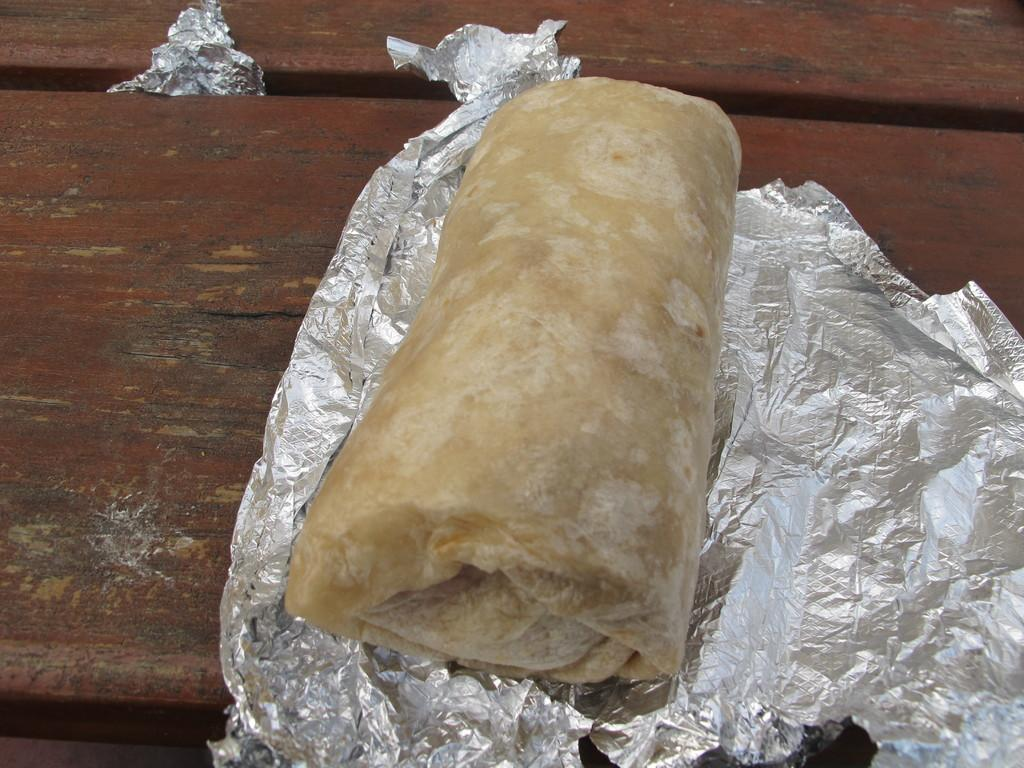What material is the plank in the image made of? The wooden plank in the image is made of wood. What is placed on the wooden plank? There is a food item wrapped in silver paper on the wooden plank. What type of notebook is visible on the wooden plank? There is no notebook present on the wooden plank in the image. 